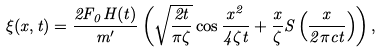Convert formula to latex. <formula><loc_0><loc_0><loc_500><loc_500>\xi ( x , t ) = \frac { 2 F _ { 0 } H ( t ) } { m ^ { \prime } } \left ( \sqrt { \frac { 2 t } { \pi \zeta } } \cos \frac { x ^ { 2 } } { 4 \zeta t } + \frac { x } { \zeta } S \left ( \frac { x } { 2 \pi c t } \right ) \right ) ,</formula> 